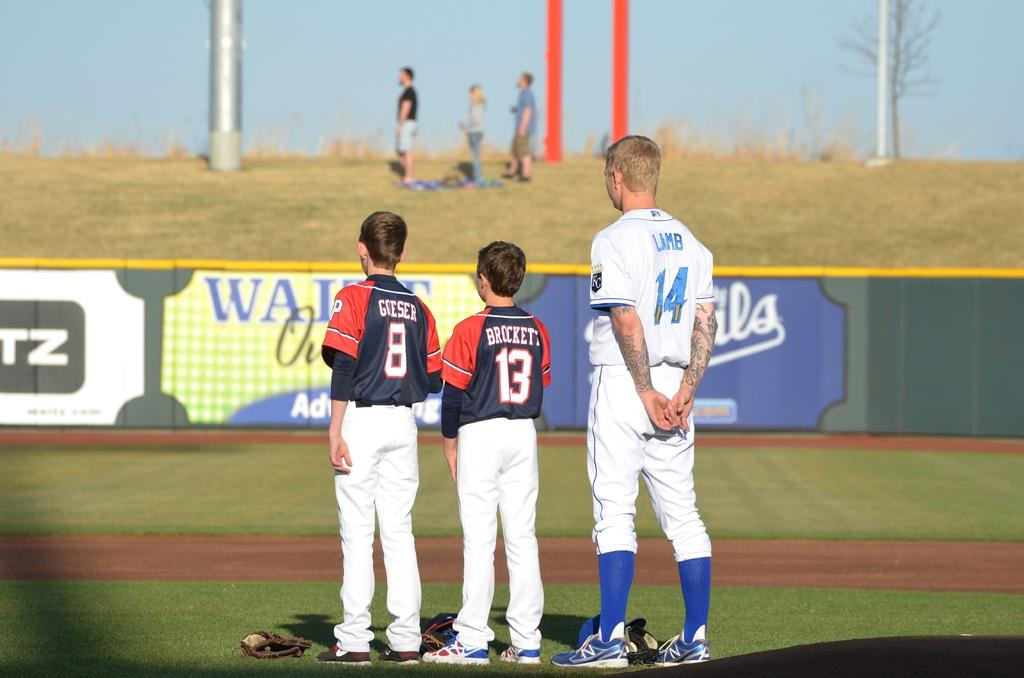<image>
Write a terse but informative summary of the picture. Two brunette boys in red and blue jerseys named Goeser and Brockett stand next to a taller blonde man in a white jersey named Lamb stand on a baseball field. 